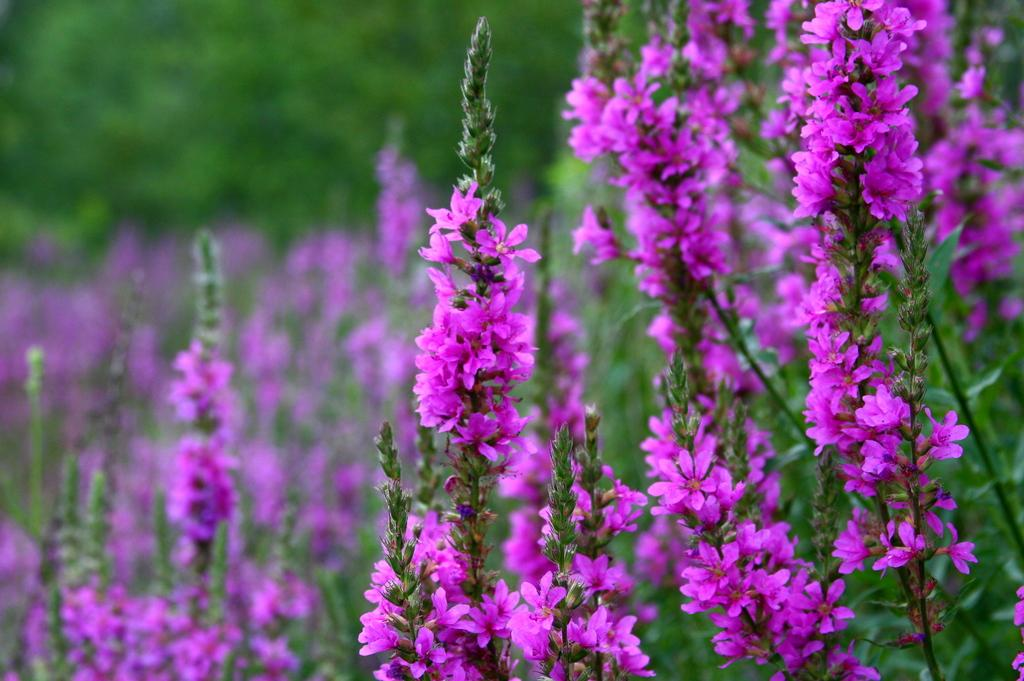What type of plants can be seen on both sides of the image? There are flower plants on the right side and the left side of the image. What can be seen at the top of the image? There is greenery at the top side of the image. Can you tell me what type of dress the river is wearing in the image? There is no river present in the image, and therefore no dress can be associated with it. 